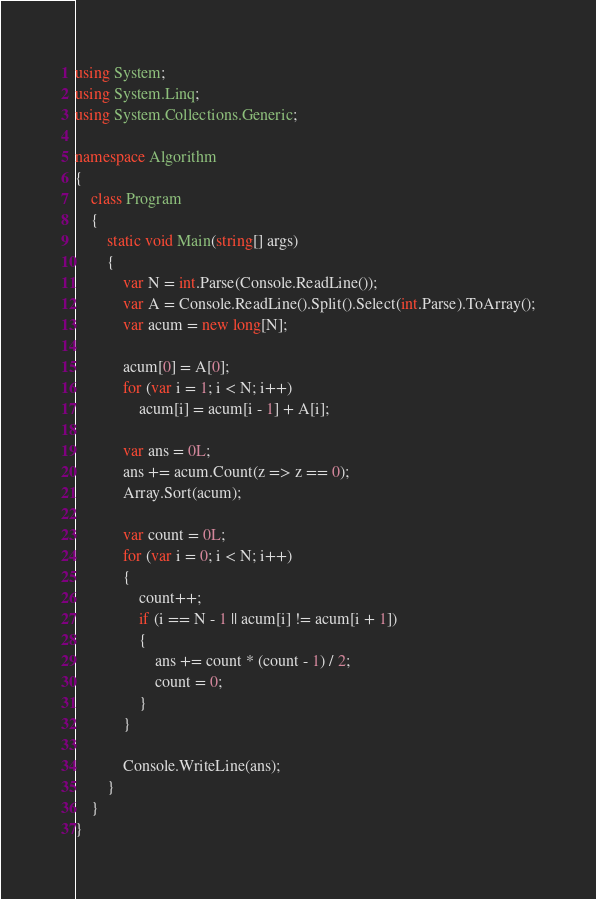<code> <loc_0><loc_0><loc_500><loc_500><_C#_>using System;
using System.Linq;
using System.Collections.Generic;

namespace Algorithm
{
    class Program
    {
        static void Main(string[] args)
        {
            var N = int.Parse(Console.ReadLine());
            var A = Console.ReadLine().Split().Select(int.Parse).ToArray();
            var acum = new long[N];

            acum[0] = A[0];
            for (var i = 1; i < N; i++)
                acum[i] = acum[i - 1] + A[i];

            var ans = 0L;
            ans += acum.Count(z => z == 0);
            Array.Sort(acum);

            var count = 0L;
            for (var i = 0; i < N; i++)
            {
                count++;
                if (i == N - 1 || acum[i] != acum[i + 1])
                {
                    ans += count * (count - 1) / 2;
                    count = 0;
                }
            }

            Console.WriteLine(ans);
        }
    }
}
</code> 